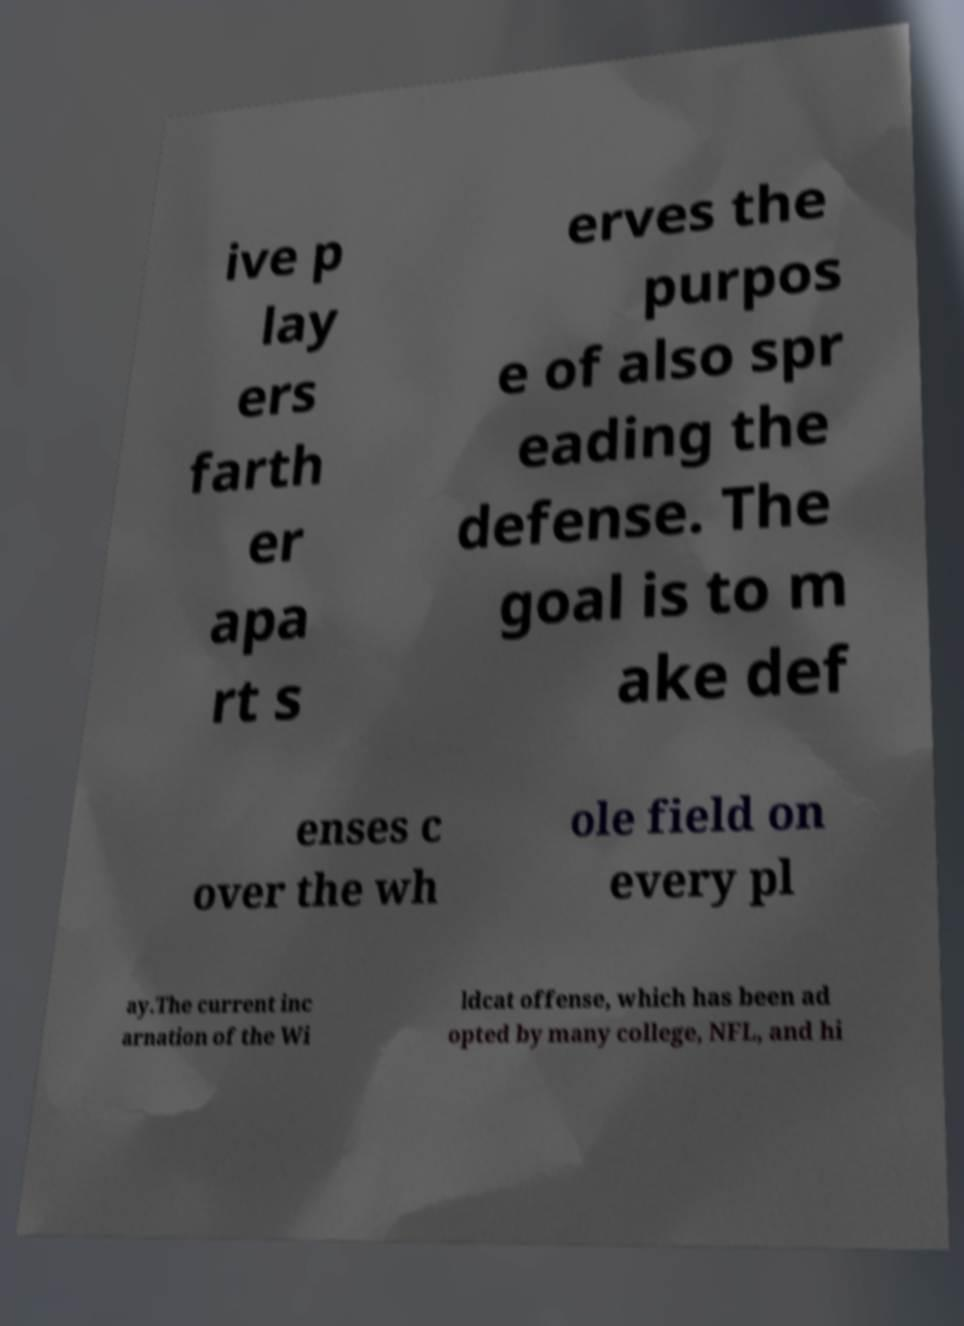Can you read and provide the text displayed in the image?This photo seems to have some interesting text. Can you extract and type it out for me? ive p lay ers farth er apa rt s erves the purpos e of also spr eading the defense. The goal is to m ake def enses c over the wh ole field on every pl ay.The current inc arnation of the Wi ldcat offense, which has been ad opted by many college, NFL, and hi 